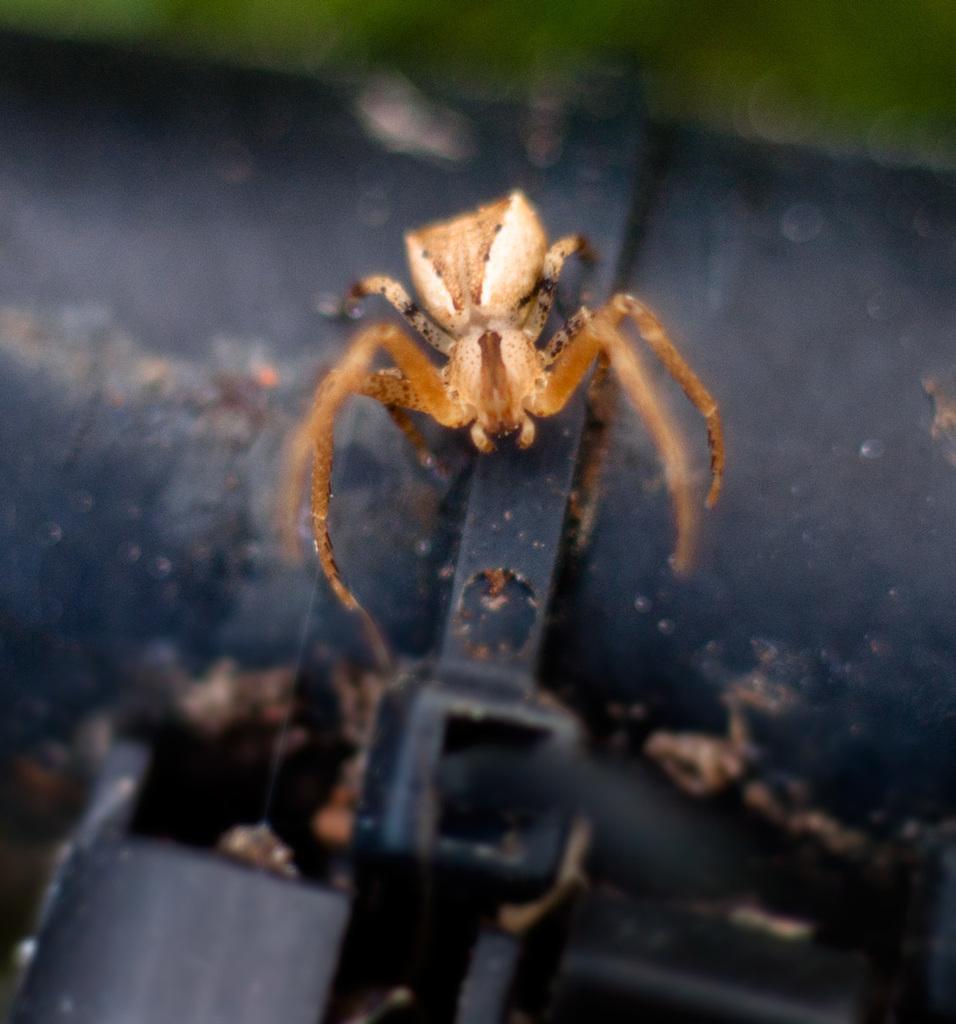Describe this image in one or two sentences. This is a macro photography of a spider with a blurred background. 